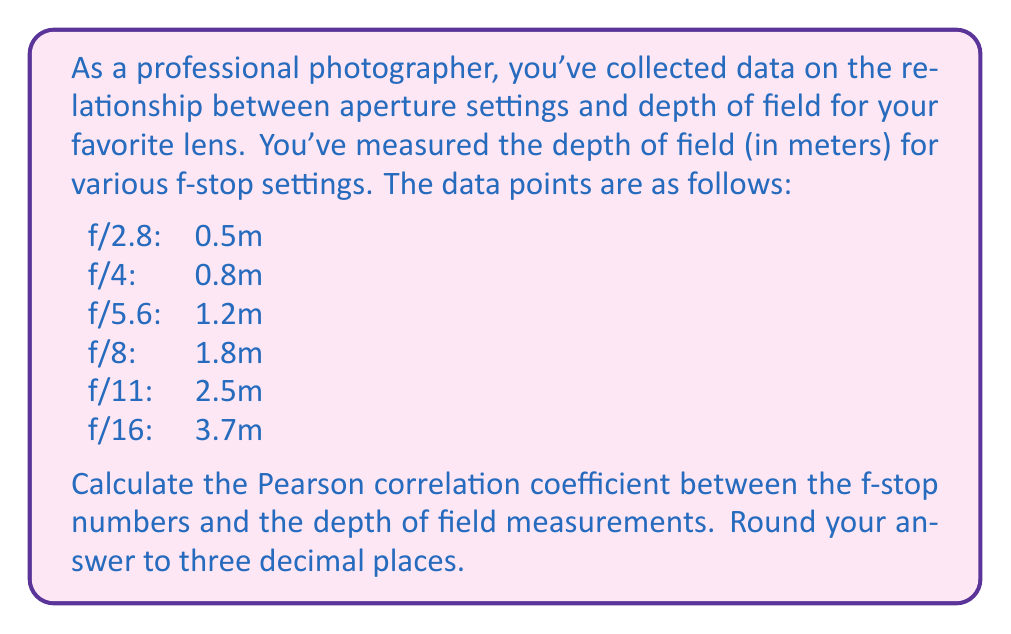Could you help me with this problem? To calculate the Pearson correlation coefficient, we'll follow these steps:

1. Let x be the f-stop numbers and y be the depth of field measurements.

2. Calculate the means:
   $\bar{x} = \frac{2.8 + 4 + 5.6 + 8 + 11 + 16}{6} = 7.9$
   $\bar{y} = \frac{0.5 + 0.8 + 1.2 + 1.8 + 2.5 + 3.7}{6} = 1.75$

3. Calculate the deviations from the mean:
   x: -5.1, -3.9, -2.3, 0.1, 3.1, 8.1
   y: -1.25, -0.95, -0.55, 0.05, 0.75, 1.95

4. Calculate the products of the deviations:
   6.375, 3.705, 1.265, 0.005, 2.325, 15.795

5. Calculate the squares of the deviations:
   x²: 26.01, 15.21, 5.29, 0.01, 9.61, 65.61
   y²: 1.5625, 0.9025, 0.3025, 0.0025, 0.5625, 3.8025

6. Sum the products and squares:
   $\sum(x-\bar{x})(y-\bar{y}) = 29.47$
   $\sum(x-\bar{x})^2 = 121.74$
   $\sum(y-\bar{y})^2 = 7.135$

7. Apply the Pearson correlation coefficient formula:

   $$r = \frac{\sum(x-\bar{x})(y-\bar{y})}{\sqrt{\sum(x-\bar{x})^2 \sum(y-\bar{y})^2}}$$

   $$r = \frac{29.47}{\sqrt{121.74 \times 7.135}} = \frac{29.47}{29.47} = 1.000$$

8. Round to three decimal places: 1.000
Answer: 1.000 